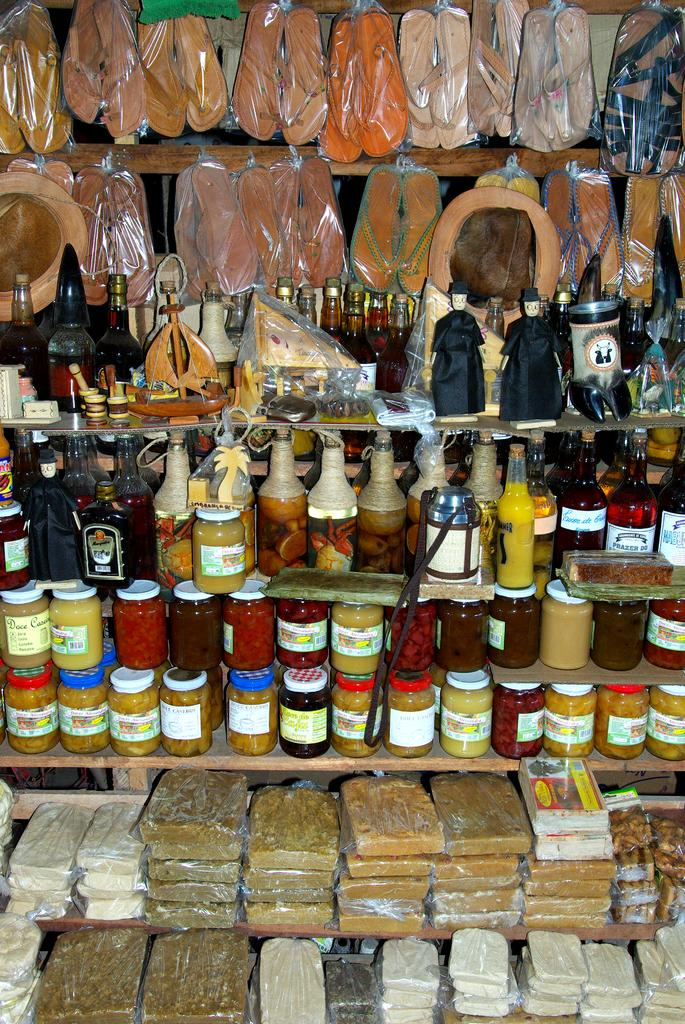What can be seen on the shelves in the image? There are shelves with objects in the image, including bottles and food items. What else is present in the image besides the shelves? There are pairs of footwear and toys in the image. How many horses can be seen in the image? There are no horses present in the image. What type of card is being used to play a game in the image? There is no card or game being played in the image. 